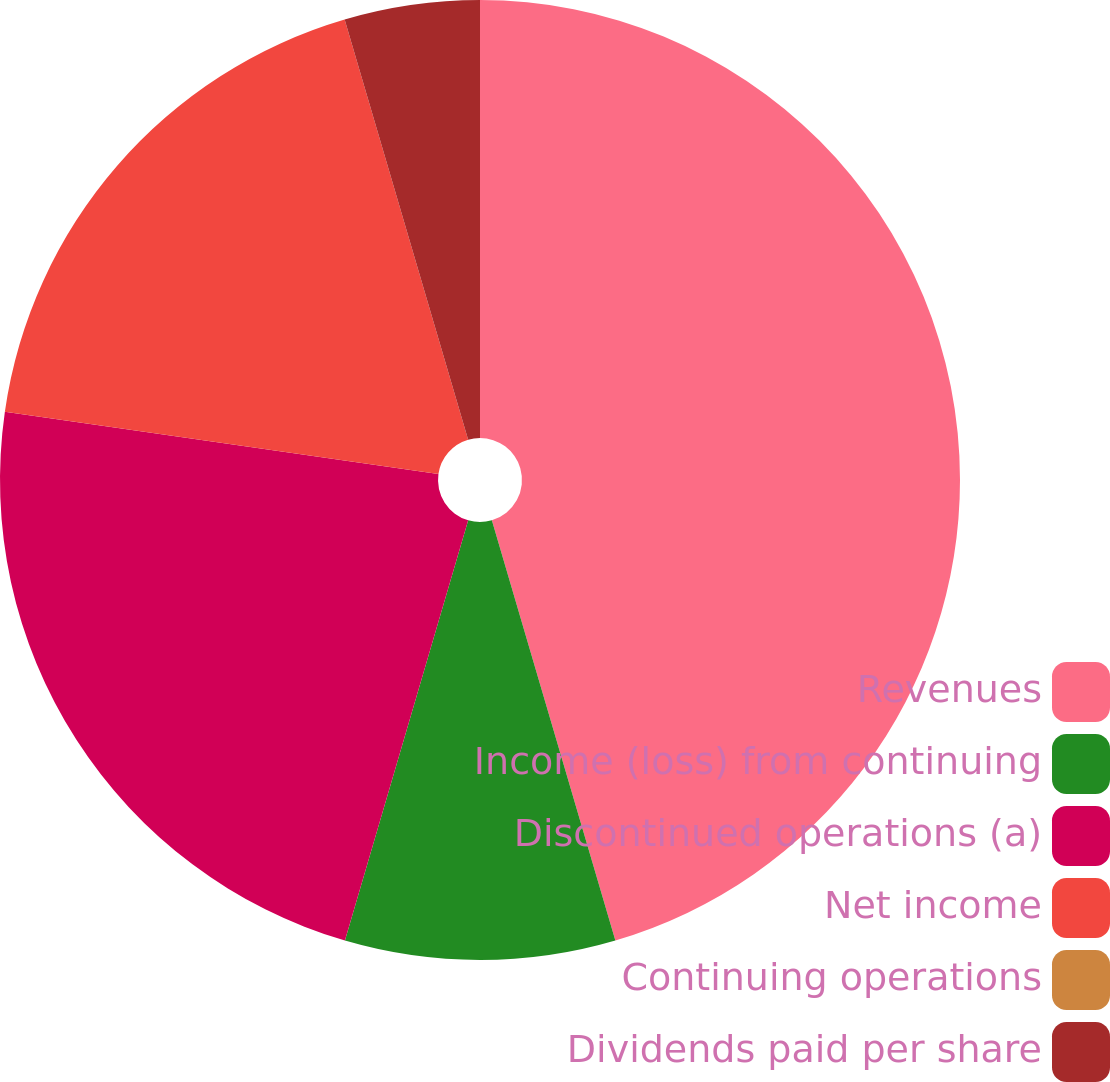<chart> <loc_0><loc_0><loc_500><loc_500><pie_chart><fcel>Revenues<fcel>Income (loss) from continuing<fcel>Discontinued operations (a)<fcel>Net income<fcel>Continuing operations<fcel>Dividends paid per share<nl><fcel>45.45%<fcel>9.09%<fcel>22.73%<fcel>18.18%<fcel>0.0%<fcel>4.55%<nl></chart> 